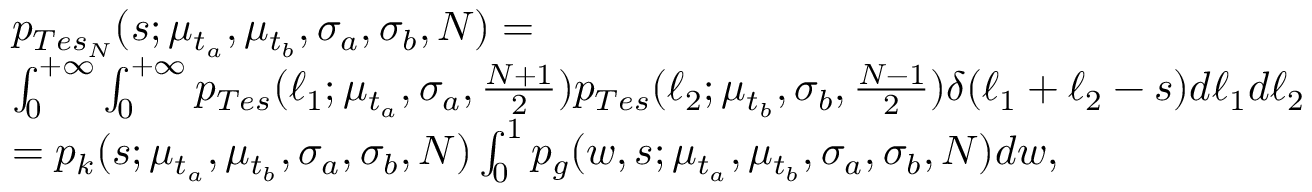Convert formula to latex. <formula><loc_0><loc_0><loc_500><loc_500>\begin{array} { r l } & { p _ { T e s _ { N } } ( s ; \mu _ { t _ { a } } , \mu _ { t _ { b } } , \sigma _ { a } , \sigma _ { b } , N ) = } \\ & { \int _ { 0 } ^ { + \infty } \int _ { 0 } ^ { + \infty } p _ { T e s } ( \ell _ { 1 } ; \mu _ { t _ { a } } , \sigma _ { a } , \frac { N + 1 } { 2 } ) p _ { T e s } ( \ell _ { 2 } ; \mu _ { t _ { b } } , \sigma _ { b } , \frac { N - 1 } { 2 } ) \delta ( \ell _ { 1 } + \ell _ { 2 } - s ) d \ell _ { 1 } d \ell _ { 2 } } \\ & { = p _ { k } ( s ; \mu _ { t _ { a } } , \mu _ { t _ { b } } , \sigma _ { a } , \sigma _ { b } , N ) \int _ { 0 } ^ { 1 } p _ { g } ( w , s ; \mu _ { t _ { a } } , \mu _ { t _ { b } } , \sigma _ { a } , \sigma _ { b } , N ) d w , } \end{array}</formula> 